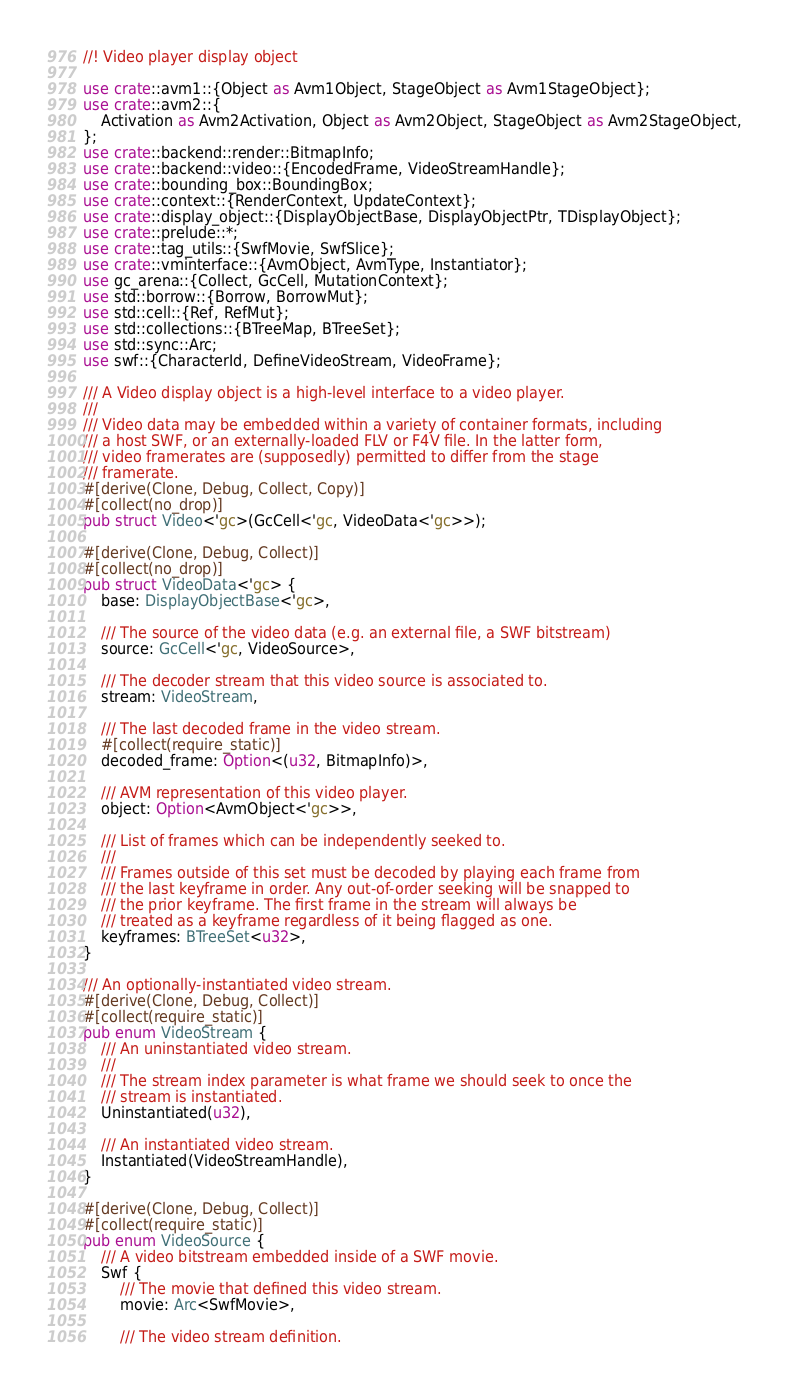Convert code to text. <code><loc_0><loc_0><loc_500><loc_500><_Rust_>//! Video player display object

use crate::avm1::{Object as Avm1Object, StageObject as Avm1StageObject};
use crate::avm2::{
    Activation as Avm2Activation, Object as Avm2Object, StageObject as Avm2StageObject,
};
use crate::backend::render::BitmapInfo;
use crate::backend::video::{EncodedFrame, VideoStreamHandle};
use crate::bounding_box::BoundingBox;
use crate::context::{RenderContext, UpdateContext};
use crate::display_object::{DisplayObjectBase, DisplayObjectPtr, TDisplayObject};
use crate::prelude::*;
use crate::tag_utils::{SwfMovie, SwfSlice};
use crate::vminterface::{AvmObject, AvmType, Instantiator};
use gc_arena::{Collect, GcCell, MutationContext};
use std::borrow::{Borrow, BorrowMut};
use std::cell::{Ref, RefMut};
use std::collections::{BTreeMap, BTreeSet};
use std::sync::Arc;
use swf::{CharacterId, DefineVideoStream, VideoFrame};

/// A Video display object is a high-level interface to a video player.
///
/// Video data may be embedded within a variety of container formats, including
/// a host SWF, or an externally-loaded FLV or F4V file. In the latter form,
/// video framerates are (supposedly) permitted to differ from the stage
/// framerate.
#[derive(Clone, Debug, Collect, Copy)]
#[collect(no_drop)]
pub struct Video<'gc>(GcCell<'gc, VideoData<'gc>>);

#[derive(Clone, Debug, Collect)]
#[collect(no_drop)]
pub struct VideoData<'gc> {
    base: DisplayObjectBase<'gc>,

    /// The source of the video data (e.g. an external file, a SWF bitstream)
    source: GcCell<'gc, VideoSource>,

    /// The decoder stream that this video source is associated to.
    stream: VideoStream,

    /// The last decoded frame in the video stream.
    #[collect(require_static)]
    decoded_frame: Option<(u32, BitmapInfo)>,

    /// AVM representation of this video player.
    object: Option<AvmObject<'gc>>,

    /// List of frames which can be independently seeked to.
    ///
    /// Frames outside of this set must be decoded by playing each frame from
    /// the last keyframe in order. Any out-of-order seeking will be snapped to
    /// the prior keyframe. The first frame in the stream will always be
    /// treated as a keyframe regardless of it being flagged as one.
    keyframes: BTreeSet<u32>,
}

/// An optionally-instantiated video stream.
#[derive(Clone, Debug, Collect)]
#[collect(require_static)]
pub enum VideoStream {
    /// An uninstantiated video stream.
    ///
    /// The stream index parameter is what frame we should seek to once the
    /// stream is instantiated.
    Uninstantiated(u32),

    /// An instantiated video stream.
    Instantiated(VideoStreamHandle),
}

#[derive(Clone, Debug, Collect)]
#[collect(require_static)]
pub enum VideoSource {
    /// A video bitstream embedded inside of a SWF movie.
    Swf {
        /// The movie that defined this video stream.
        movie: Arc<SwfMovie>,

        /// The video stream definition.</code> 